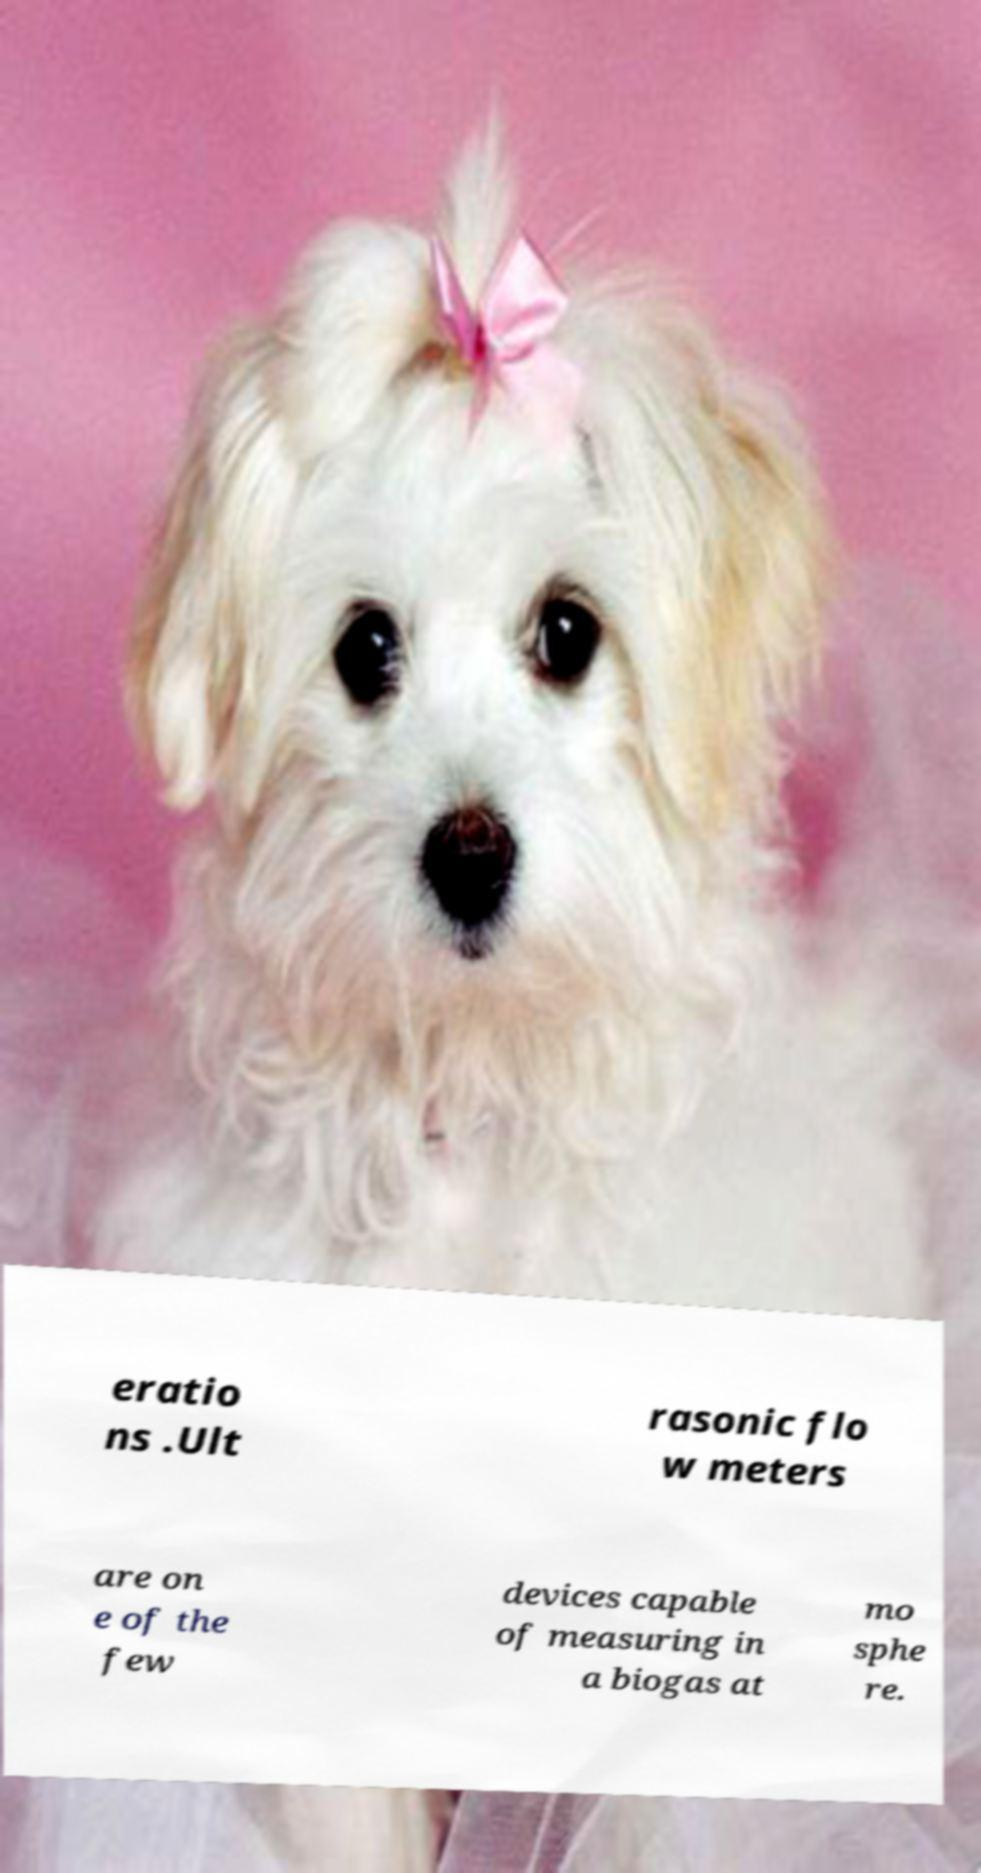For documentation purposes, I need the text within this image transcribed. Could you provide that? eratio ns .Ult rasonic flo w meters are on e of the few devices capable of measuring in a biogas at mo sphe re. 